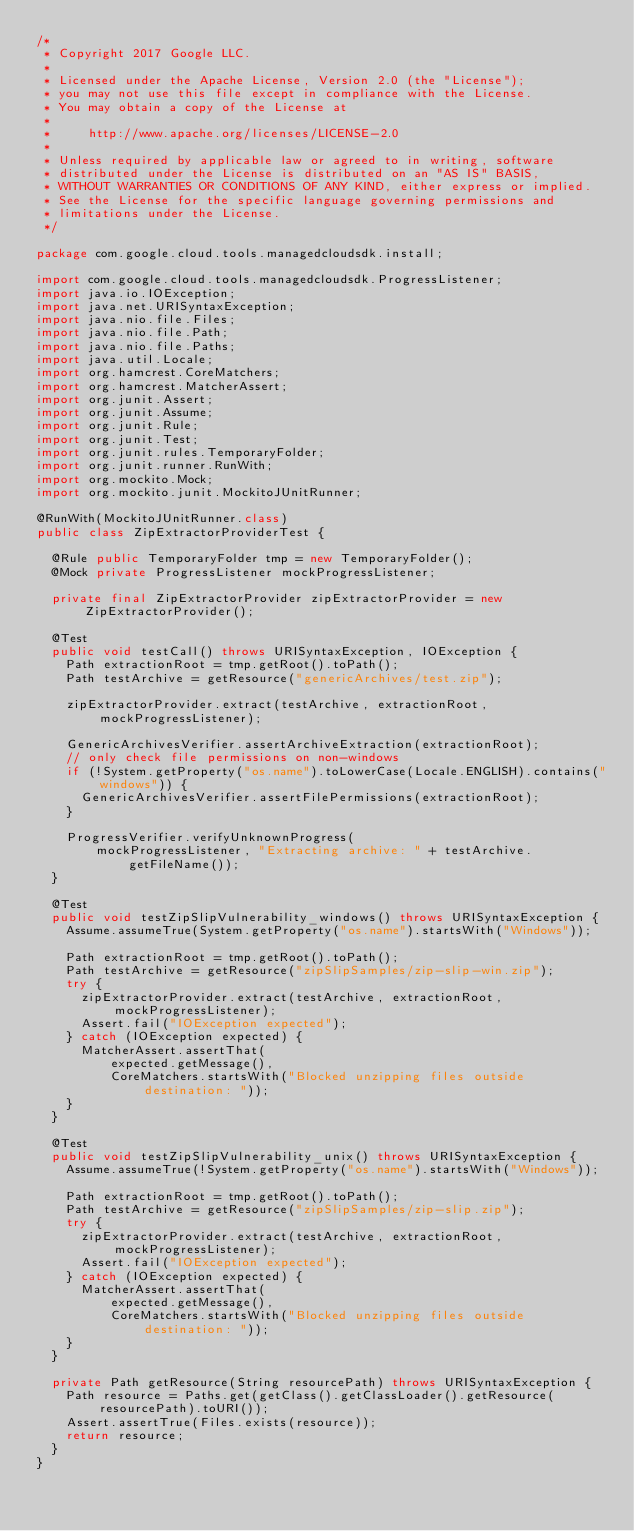<code> <loc_0><loc_0><loc_500><loc_500><_Java_>/*
 * Copyright 2017 Google LLC.
 *
 * Licensed under the Apache License, Version 2.0 (the "License");
 * you may not use this file except in compliance with the License.
 * You may obtain a copy of the License at
 *
 *     http://www.apache.org/licenses/LICENSE-2.0
 *
 * Unless required by applicable law or agreed to in writing, software
 * distributed under the License is distributed on an "AS IS" BASIS,
 * WITHOUT WARRANTIES OR CONDITIONS OF ANY KIND, either express or implied.
 * See the License for the specific language governing permissions and
 * limitations under the License.
 */

package com.google.cloud.tools.managedcloudsdk.install;

import com.google.cloud.tools.managedcloudsdk.ProgressListener;
import java.io.IOException;
import java.net.URISyntaxException;
import java.nio.file.Files;
import java.nio.file.Path;
import java.nio.file.Paths;
import java.util.Locale;
import org.hamcrest.CoreMatchers;
import org.hamcrest.MatcherAssert;
import org.junit.Assert;
import org.junit.Assume;
import org.junit.Rule;
import org.junit.Test;
import org.junit.rules.TemporaryFolder;
import org.junit.runner.RunWith;
import org.mockito.Mock;
import org.mockito.junit.MockitoJUnitRunner;

@RunWith(MockitoJUnitRunner.class)
public class ZipExtractorProviderTest {

  @Rule public TemporaryFolder tmp = new TemporaryFolder();
  @Mock private ProgressListener mockProgressListener;

  private final ZipExtractorProvider zipExtractorProvider = new ZipExtractorProvider();

  @Test
  public void testCall() throws URISyntaxException, IOException {
    Path extractionRoot = tmp.getRoot().toPath();
    Path testArchive = getResource("genericArchives/test.zip");

    zipExtractorProvider.extract(testArchive, extractionRoot, mockProgressListener);

    GenericArchivesVerifier.assertArchiveExtraction(extractionRoot);
    // only check file permissions on non-windows
    if (!System.getProperty("os.name").toLowerCase(Locale.ENGLISH).contains("windows")) {
      GenericArchivesVerifier.assertFilePermissions(extractionRoot);
    }

    ProgressVerifier.verifyUnknownProgress(
        mockProgressListener, "Extracting archive: " + testArchive.getFileName());
  }

  @Test
  public void testZipSlipVulnerability_windows() throws URISyntaxException {
    Assume.assumeTrue(System.getProperty("os.name").startsWith("Windows"));

    Path extractionRoot = tmp.getRoot().toPath();
    Path testArchive = getResource("zipSlipSamples/zip-slip-win.zip");
    try {
      zipExtractorProvider.extract(testArchive, extractionRoot, mockProgressListener);
      Assert.fail("IOException expected");
    } catch (IOException expected) {
      MatcherAssert.assertThat(
          expected.getMessage(),
          CoreMatchers.startsWith("Blocked unzipping files outside destination: "));
    }
  }

  @Test
  public void testZipSlipVulnerability_unix() throws URISyntaxException {
    Assume.assumeTrue(!System.getProperty("os.name").startsWith("Windows"));

    Path extractionRoot = tmp.getRoot().toPath();
    Path testArchive = getResource("zipSlipSamples/zip-slip.zip");
    try {
      zipExtractorProvider.extract(testArchive, extractionRoot, mockProgressListener);
      Assert.fail("IOException expected");
    } catch (IOException expected) {
      MatcherAssert.assertThat(
          expected.getMessage(),
          CoreMatchers.startsWith("Blocked unzipping files outside destination: "));
    }
  }

  private Path getResource(String resourcePath) throws URISyntaxException {
    Path resource = Paths.get(getClass().getClassLoader().getResource(resourcePath).toURI());
    Assert.assertTrue(Files.exists(resource));
    return resource;
  }
}
</code> 